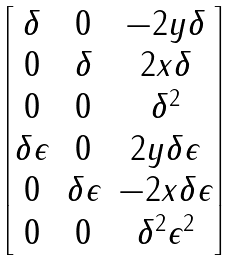<formula> <loc_0><loc_0><loc_500><loc_500>\begin{bmatrix} \delta & 0 & - 2 y \delta \\ 0 & \delta & 2 x \delta \\ 0 & 0 & \delta ^ { 2 } \\ \delta \epsilon & 0 & 2 y \delta \epsilon \\ 0 & \delta \epsilon & - 2 x \delta \epsilon \\ 0 & 0 & \delta ^ { 2 } \epsilon ^ { 2 } \end{bmatrix}</formula> 